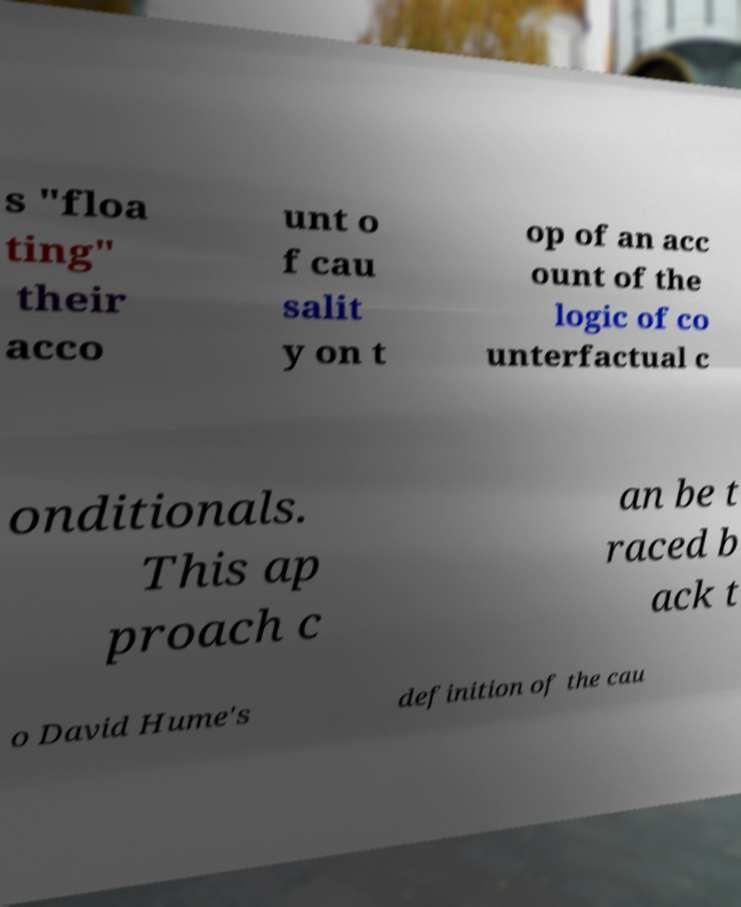There's text embedded in this image that I need extracted. Can you transcribe it verbatim? s "floa ting" their acco unt o f cau salit y on t op of an acc ount of the logic of co unterfactual c onditionals. This ap proach c an be t raced b ack t o David Hume's definition of the cau 